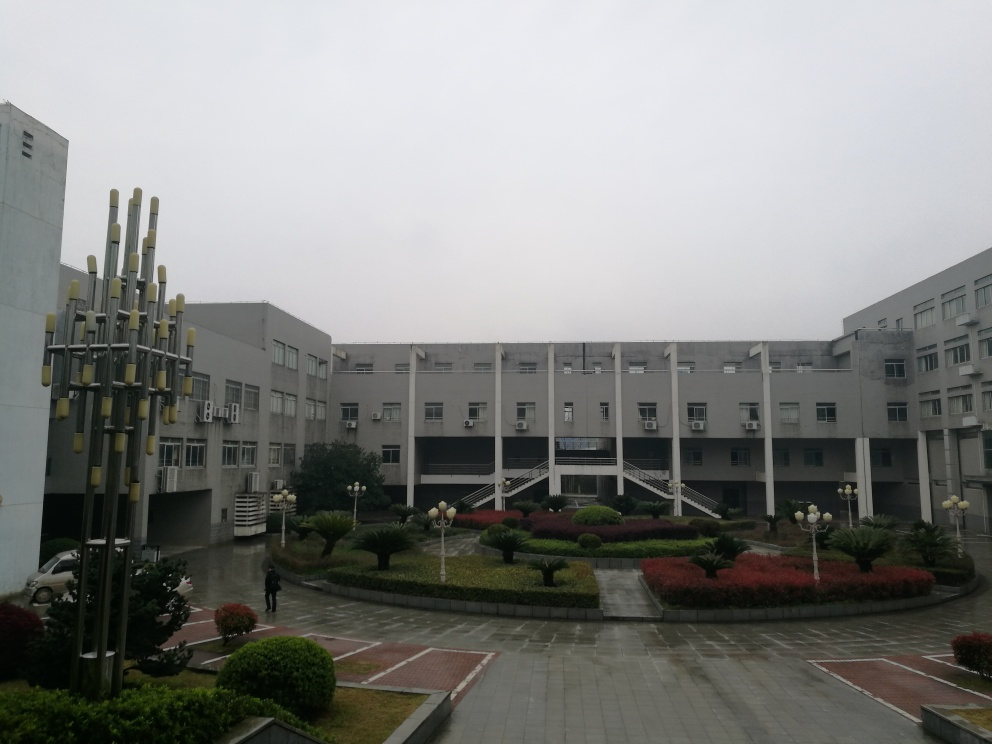What is the overall clarity of the image?
 high 